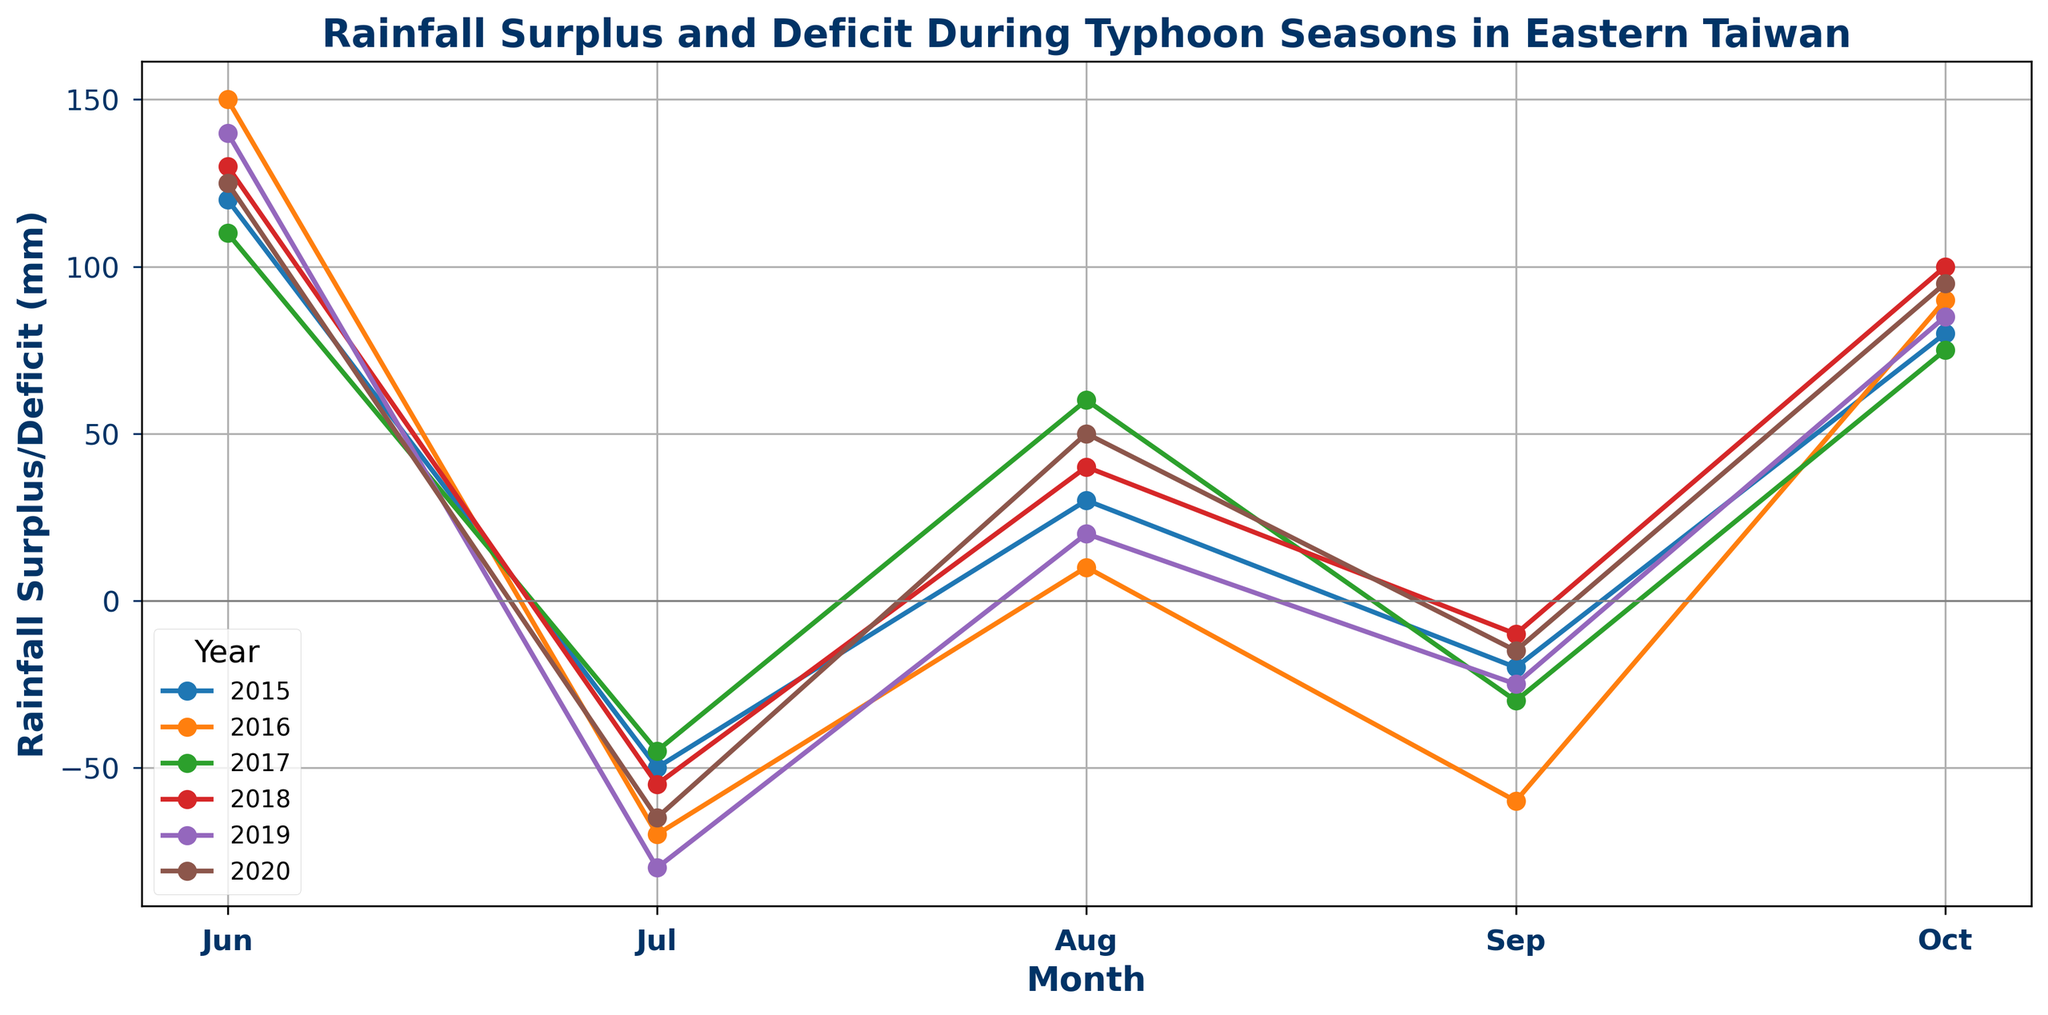What trend do you observe with the Rainfall Surplus or Deficit across all years during the month of July? By examining the plot lines for the month of July across all years, it becomes evident that there is a consistently negative Rainfall Surplus or Deficit for July. This indicates that each year July experiences a deficit in rainfall.
Answer: July consistently experiences a rainfall deficit Which year has the highest positive surplus in October? Observing the data points for October across all years, the highest positive surplus is seen in 2018, where the value reaches 100 mm.
Answer: 2018 Which month shows the highest rainfall deficit in 2019, and what is its value? In 2019, the month of July exhibits the highest rainfall deficit. By looking at the plot for 2019, the value in July is -80 mm, which is the most negative for the year.
Answer: July, -80 mm Compare the rainfall surplus in August 2016 and August 2020. Which year had a higher surplus and by how much? The surplus for August 2016 is 10 mm while for August 2020, it is 50 mm. By subtracting these values (50 mm - 10 mm), it shows that August 2020 had a higher surplus by 40 mm.
Answer: 2020, 40 mm Which year had the smallest variation in rainfall surplus or deficit during the typhoon season? To find the smallest variation, we look for the year with the smallest difference between the highest and lowest values in rainfall surplus/deficit. Calculating the ranges, 2015: 120 to -50, 2016: 150 to -70, 2017: 110 to -45, 2018: 130 to -55, 2019: 140 to -80, 2020: 125 to -65. 2017 had the smallest range (110 to -45), which is 155 mm.
Answer: 2017 In which year did the month of June experience the highest surplus? By examining the June data points across all years, 2016 has the highest June rainfall surplus with a value of 150 mm.
Answer: 2016 Considering the entire dataset, what is the average rainfall surplus for the month of October? The October values are: 80, 90, 75, 100, 85, 95. Sum these values to get 525. There are 6 occurrences, so the average is 525/6 = 87.5 mm.
Answer: 87.5 mm What is the general trend in rainfall surplus or deficit from June to October for 2017? Starting from June to October in 2017, the rainfall surplus/deficit values are 110, -45, 60, -30, 75. The trend alternates with surplus in June (110 mm), a deficit in July (-45 mm), surplus in August (60 mm), a deficit in September (-30 mm), and again surplus in October (75 mm).
Answer: Alternating, starting with surplus Which month shows the highest frequency of deficit across the dataset, and how many times does this occur? Deficit can be identified by negative values. Tallying the negative values: June (0), July (6), August (0), September (5), and October (0). The month of July has the highest frequency with 6 deficits.
Answer: July, 6 times 